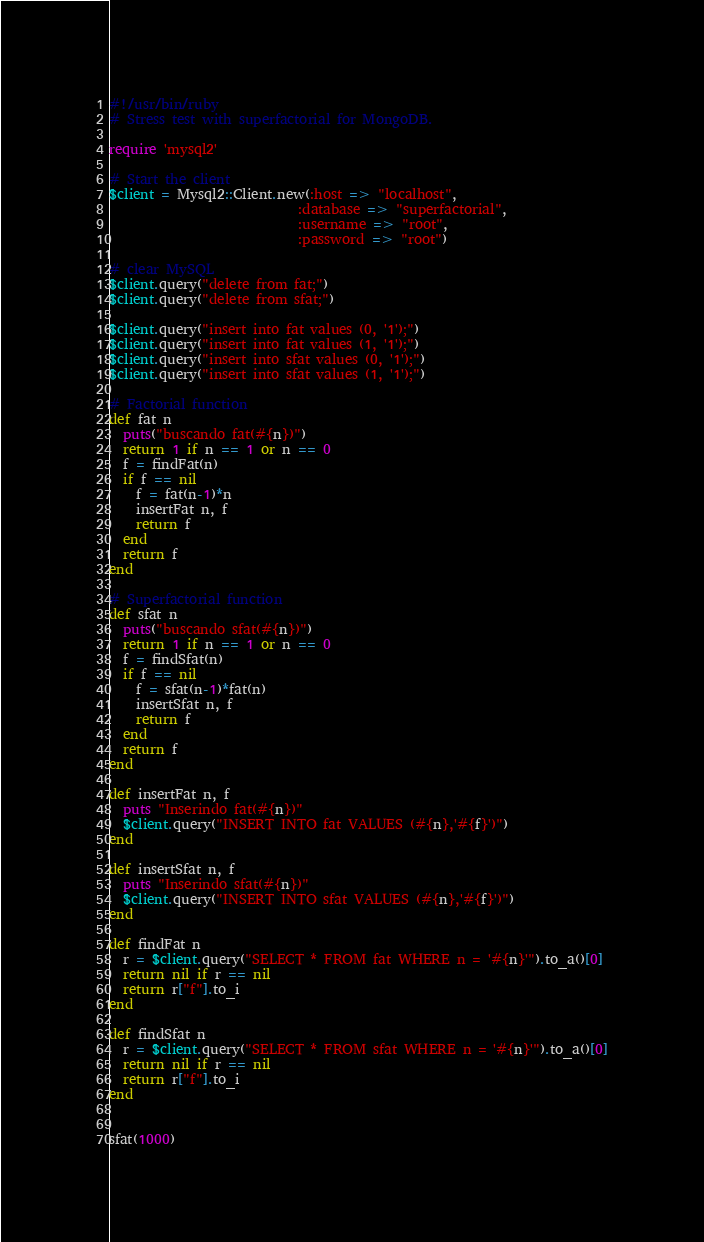Convert code to text. <code><loc_0><loc_0><loc_500><loc_500><_Ruby_>#!/usr/bin/ruby
# Stress test with superfactorial for MongoDB.

require 'mysql2'

# Start the client
$client = Mysql2::Client.new(:host => "localhost",
                            :database => "superfactorial",
                            :username => "root",
                            :password => "root")

# clear MySQL
$client.query("delete from fat;")
$client.query("delete from sfat;")

$client.query("insert into fat values (0, '1');")
$client.query("insert into fat values (1, '1');")
$client.query("insert into sfat values (0, '1');")
$client.query("insert into sfat values (1, '1');")

# Factorial function
def fat n
  puts("buscando fat(#{n})")
  return 1 if n == 1 or n == 0
  f = findFat(n)
  if f == nil
    f = fat(n-1)*n
    insertFat n, f
    return f
  end
  return f
end

# Superfactorial function
def sfat n
  puts("buscando sfat(#{n})")
  return 1 if n == 1 or n == 0
  f = findSfat(n)
  if f == nil
    f = sfat(n-1)*fat(n)
    insertSfat n, f
    return f
  end
  return f
end

def insertFat n, f
  puts "Inserindo fat(#{n})"
  $client.query("INSERT INTO fat VALUES (#{n},'#{f}')")
end

def insertSfat n, f
  puts "Inserindo sfat(#{n})"
  $client.query("INSERT INTO sfat VALUES (#{n},'#{f}')")
end

def findFat n
  r = $client.query("SELECT * FROM fat WHERE n = '#{n}'").to_a()[0]
  return nil if r == nil
  return r["f"].to_i
end

def findSfat n
  r = $client.query("SELECT * FROM sfat WHERE n = '#{n}'").to_a()[0]
  return nil if r == nil
  return r["f"].to_i
end


sfat(1000)
</code> 